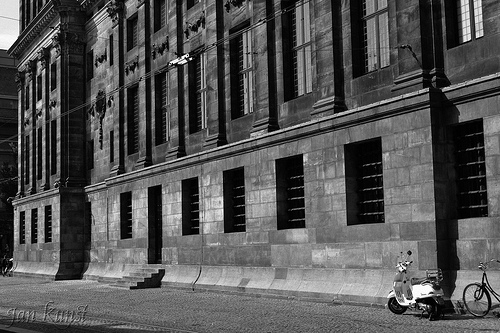Is there a bench on the sidewalk? No, there is no bench visible on the sidewalk. 